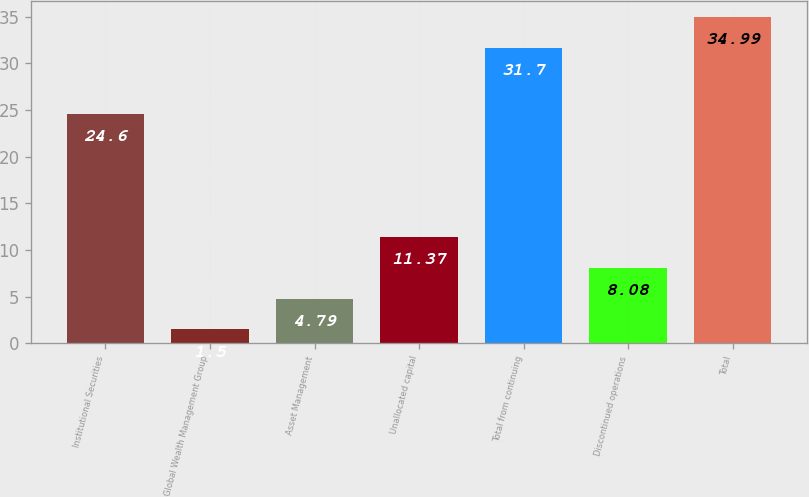Convert chart to OTSL. <chart><loc_0><loc_0><loc_500><loc_500><bar_chart><fcel>Institutional Securities<fcel>Global Wealth Management Group<fcel>Asset Management<fcel>Unallocated capital<fcel>Total from continuing<fcel>Discontinued operations<fcel>Total<nl><fcel>24.6<fcel>1.5<fcel>4.79<fcel>11.37<fcel>31.7<fcel>8.08<fcel>34.99<nl></chart> 